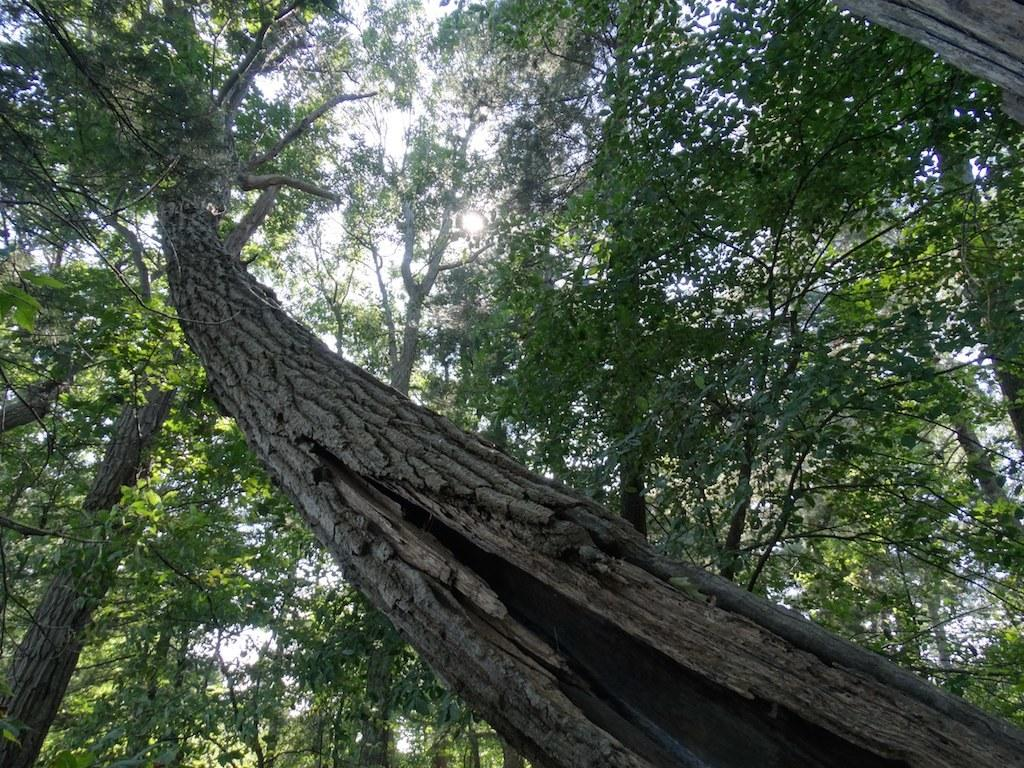What type of vegetation can be seen in the image? There are trees in the image. What part of the natural environment is visible in the image? The sky is visible in the image. What type of cream can be seen on the trees in the image? There is no cream present on the trees in the image. What type of grass is visible in the image? There is no grass visible in the image; only trees and the sky are present. 